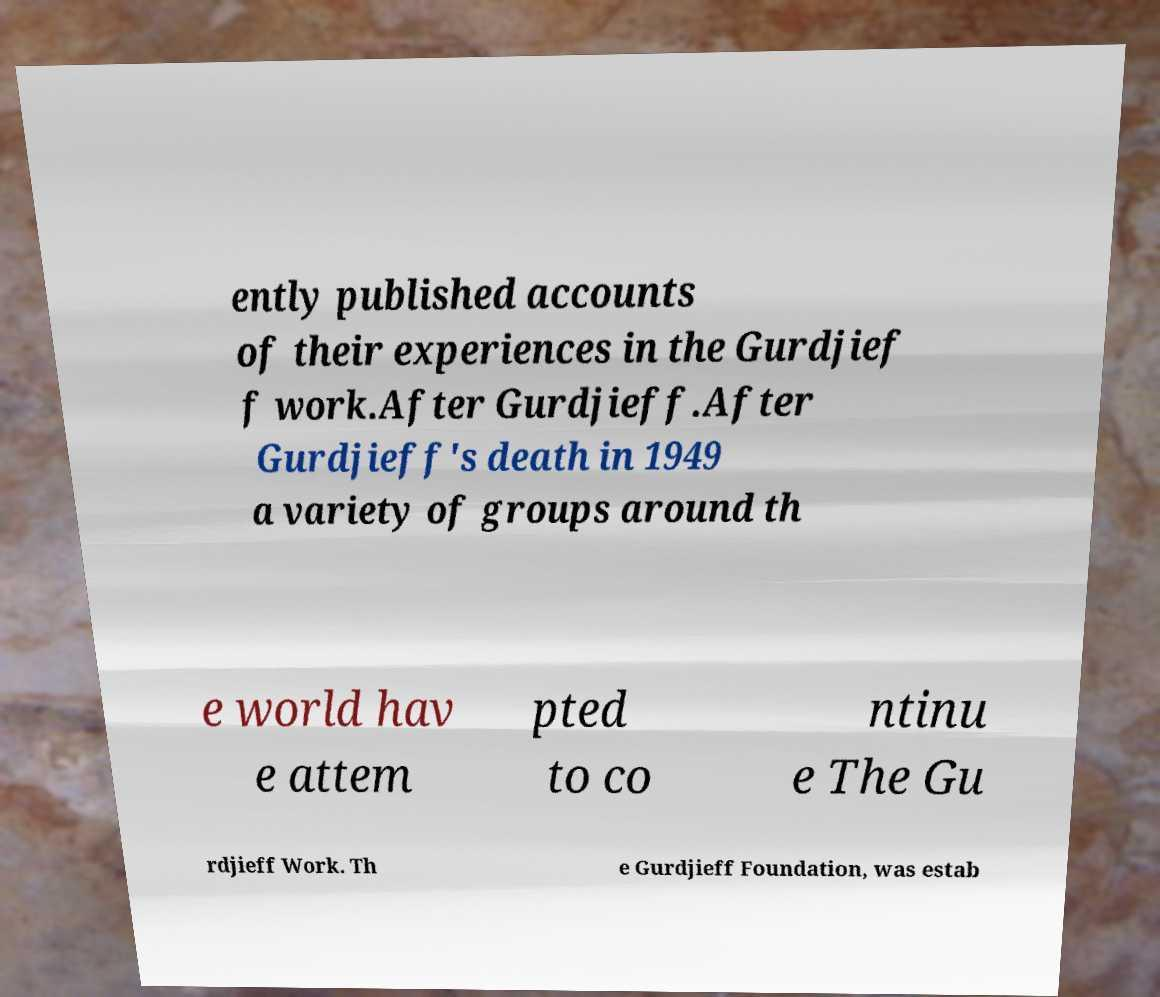Can you accurately transcribe the text from the provided image for me? ently published accounts of their experiences in the Gurdjief f work.After Gurdjieff.After Gurdjieff's death in 1949 a variety of groups around th e world hav e attem pted to co ntinu e The Gu rdjieff Work. Th e Gurdjieff Foundation, was estab 